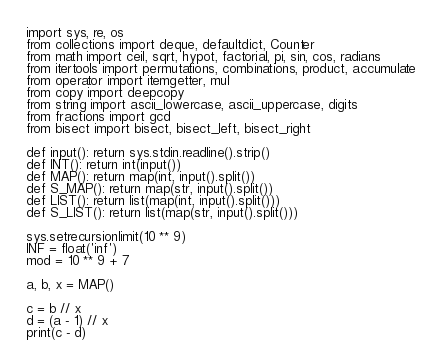<code> <loc_0><loc_0><loc_500><loc_500><_Python_>import sys, re, os
from collections import deque, defaultdict, Counter
from math import ceil, sqrt, hypot, factorial, pi, sin, cos, radians
from itertools import permutations, combinations, product, accumulate
from operator import itemgetter, mul
from copy import deepcopy
from string import ascii_lowercase, ascii_uppercase, digits
from fractions import gcd
from bisect import bisect, bisect_left, bisect_right

def input(): return sys.stdin.readline().strip()
def INT(): return int(input())
def MAP(): return map(int, input().split())
def S_MAP(): return map(str, input().split())
def LIST(): return list(map(int, input().split()))
def S_LIST(): return list(map(str, input().split()))
 
sys.setrecursionlimit(10 ** 9)
INF = float('inf')
mod = 10 ** 9 + 7

a, b, x = MAP()

c = b // x
d = (a - 1) // x
print(c - d)</code> 